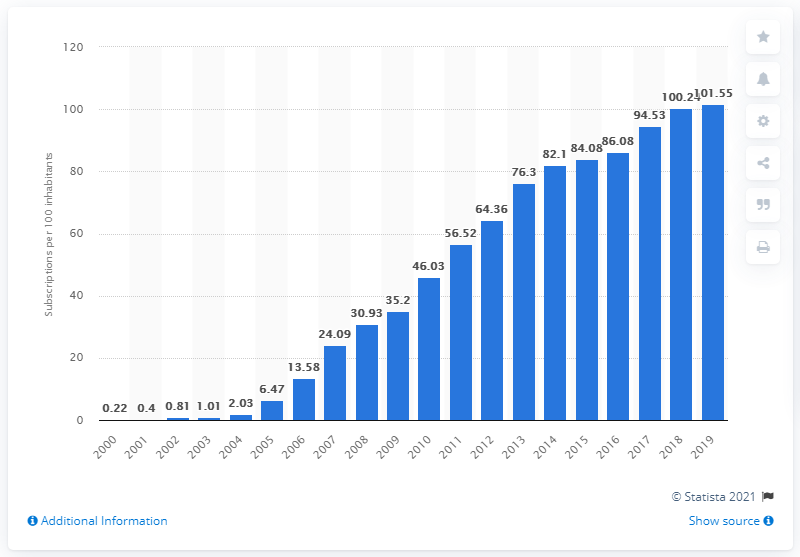Draw attention to some important aspects in this diagram. In Bangladesh, the number of mobile subscriptions per 100 people increased from 101.55 in 2000 to 133.79 in 2019. In 2000, the number of mobile cellular subscriptions per 100 inhabitants in Bangladesh was. 